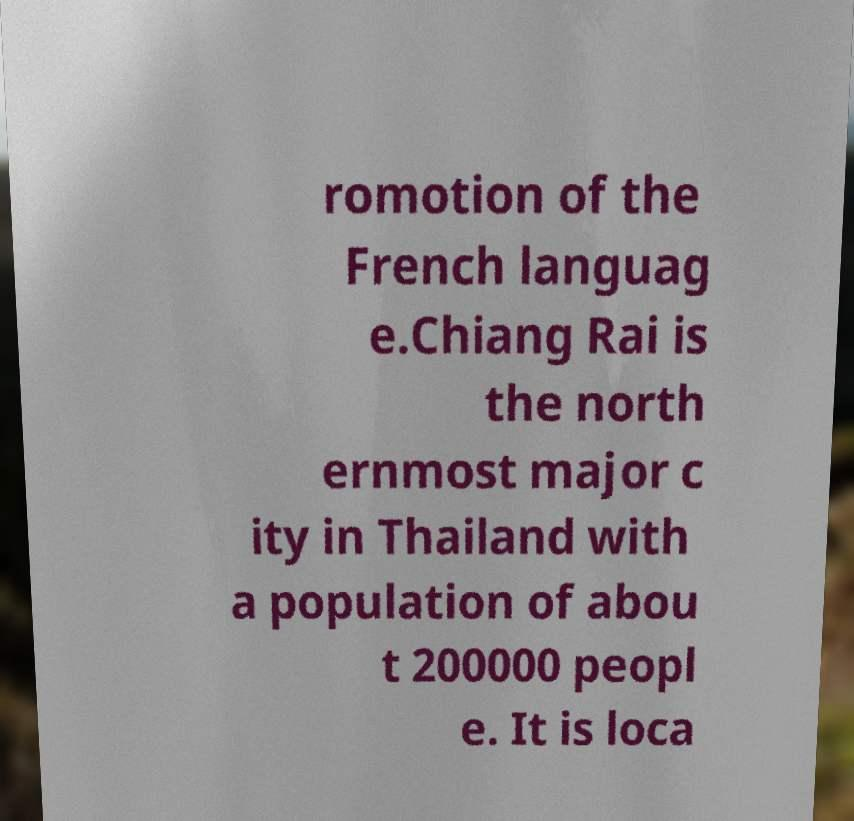Can you read and provide the text displayed in the image?This photo seems to have some interesting text. Can you extract and type it out for me? romotion of the French languag e.Chiang Rai is the north ernmost major c ity in Thailand with a population of abou t 200000 peopl e. It is loca 